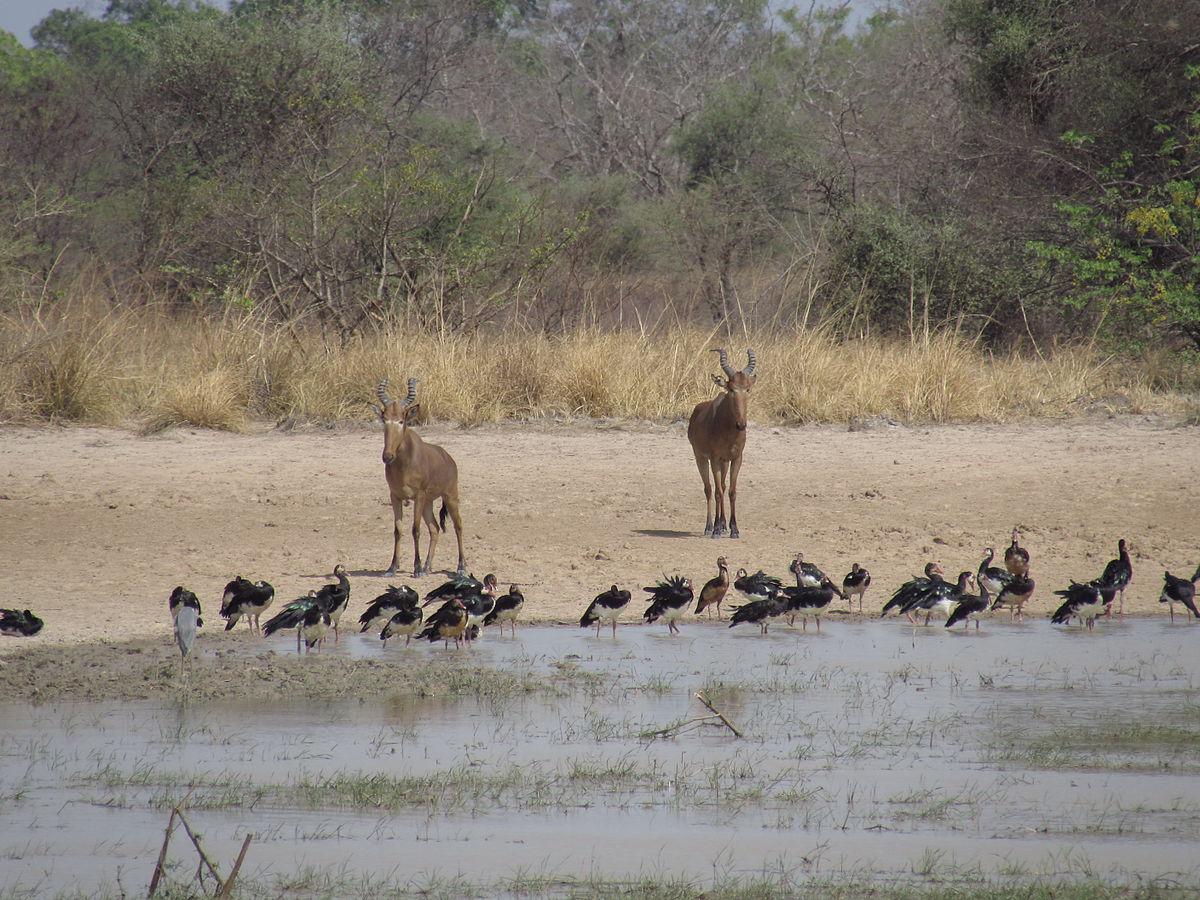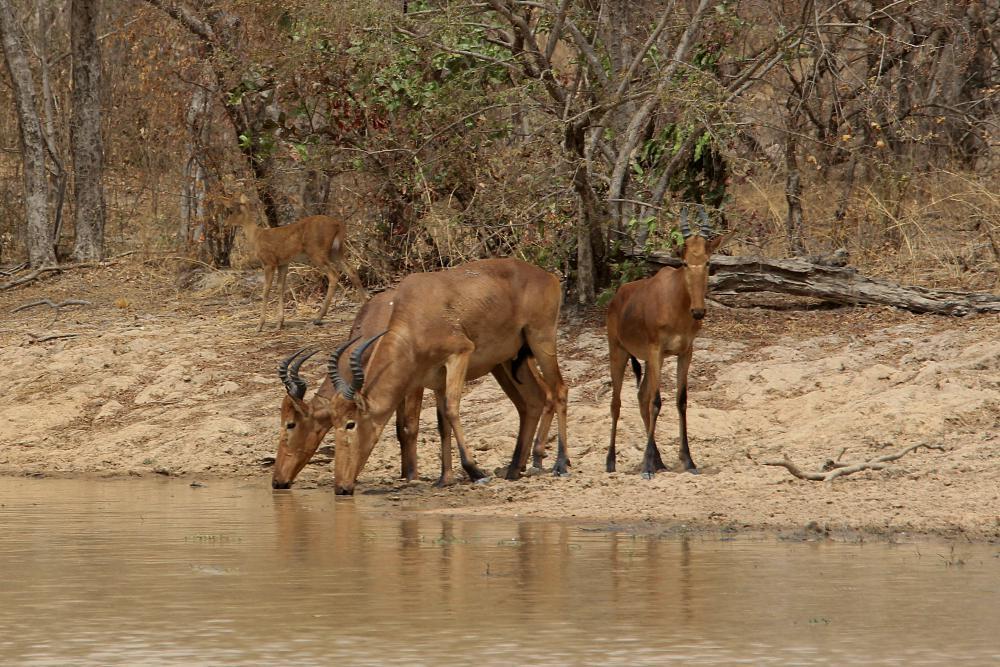The first image is the image on the left, the second image is the image on the right. Given the left and right images, does the statement "In at least one image, animals are drinking water." hold true? Answer yes or no. Yes. 